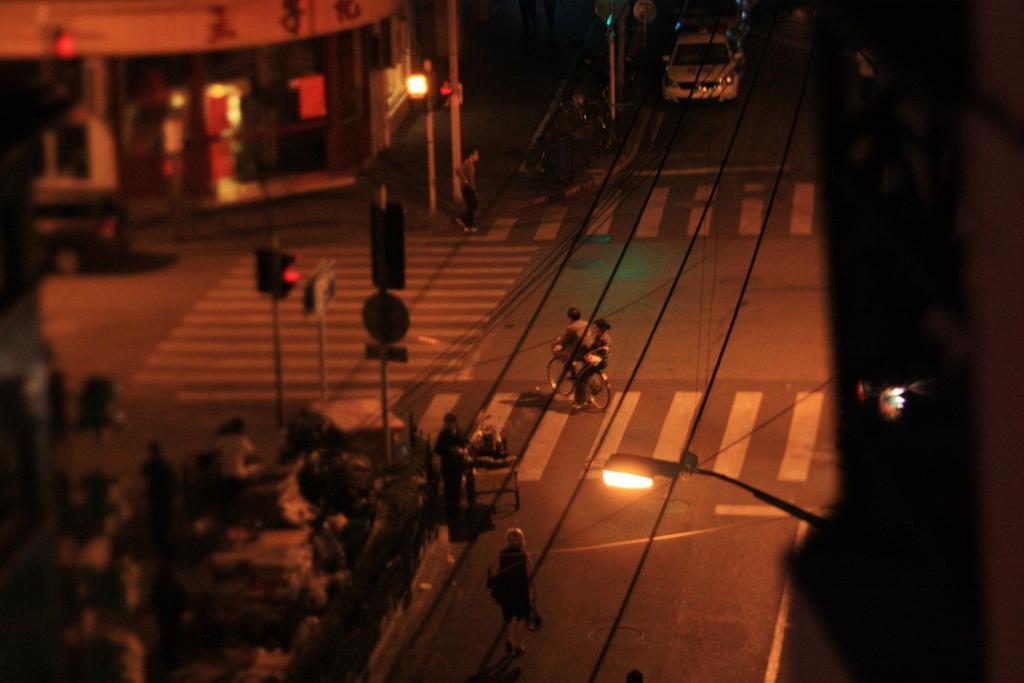In one or two sentences, can you explain what this image depicts? In the center of the image we can see two persons sitting on a bicycle. In the foreground we can see a group of people standing on the ground and some objects placed on the ground, we can also see traffic lights, poles and sign boards. On the right side of the image we can see light pole, cables. In the background, we can see a building with windows and door, a vehicle parked on the road. 